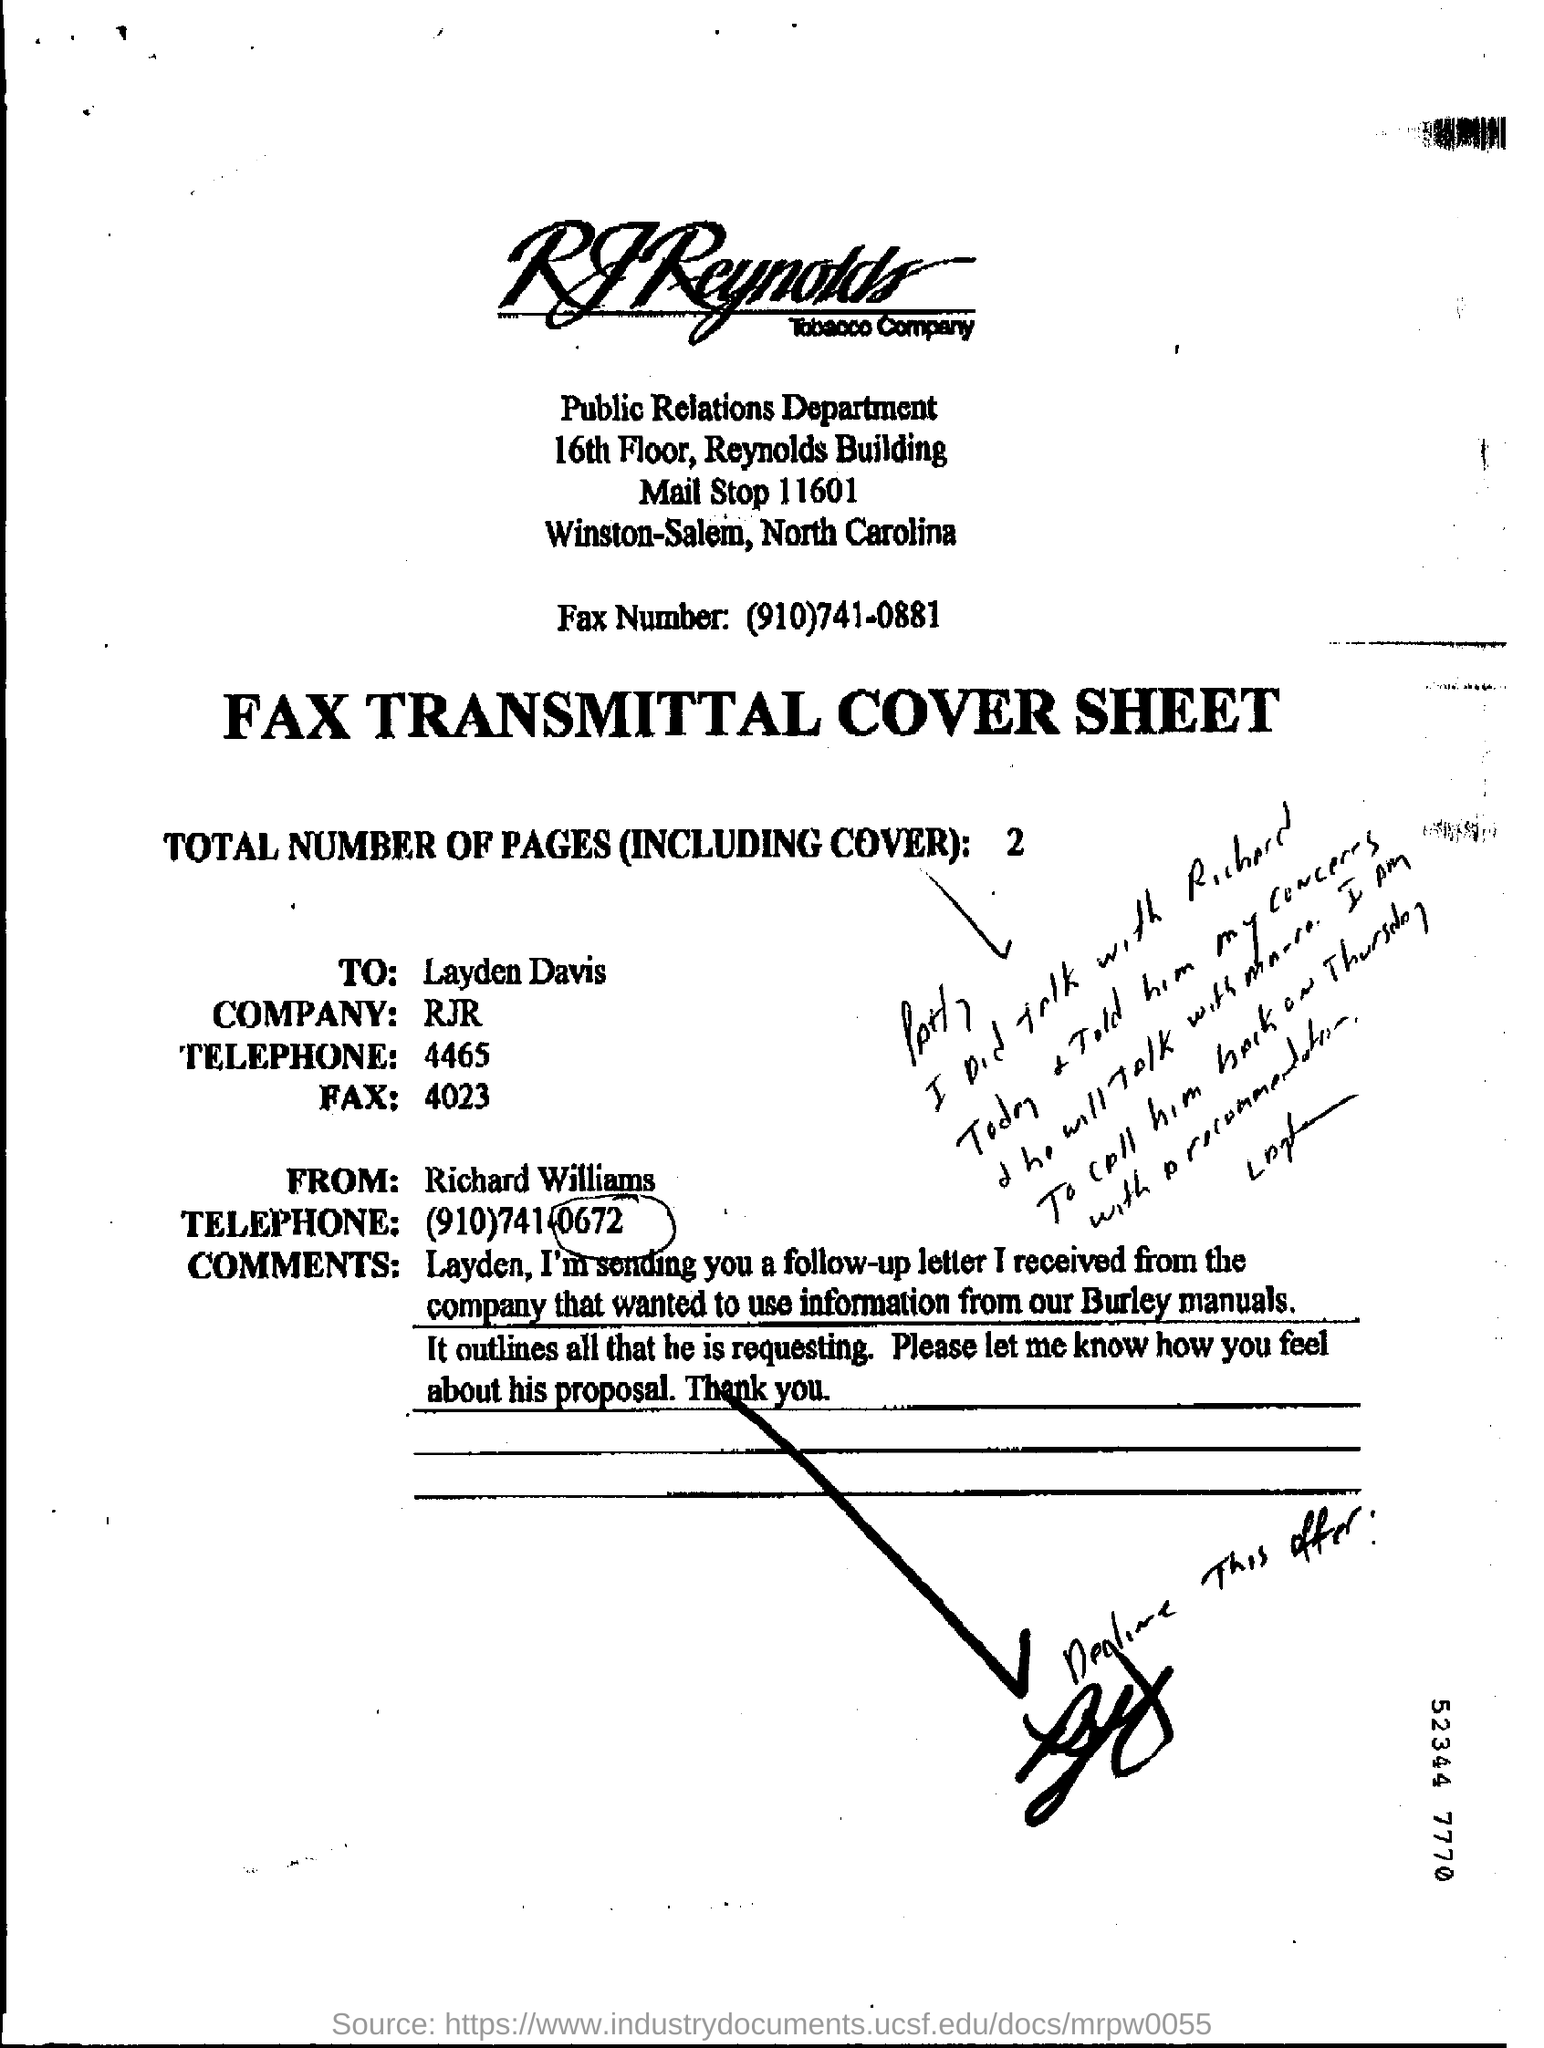Point out several critical features in this image. This is a cover sheet for a fax transmission. The fax is being sent to Layden Davis. The telephone number of Richard Williams is (910)741-0672. The sender of the FAX is Richard Williams. 